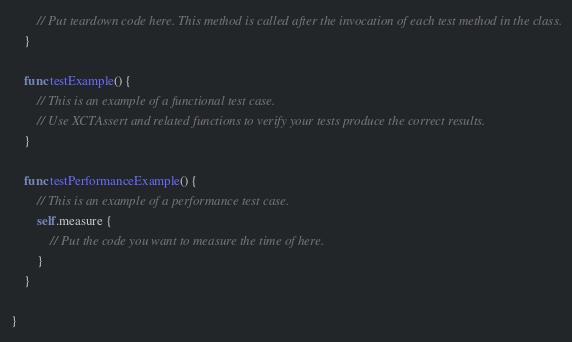Convert code to text. <code><loc_0><loc_0><loc_500><loc_500><_Swift_>        // Put teardown code here. This method is called after the invocation of each test method in the class.
    }

    func testExample() {
        // This is an example of a functional test case.
        // Use XCTAssert and related functions to verify your tests produce the correct results.
    }

    func testPerformanceExample() {
        // This is an example of a performance test case.
        self.measure {
            // Put the code you want to measure the time of here.
        }
    }

}
</code> 